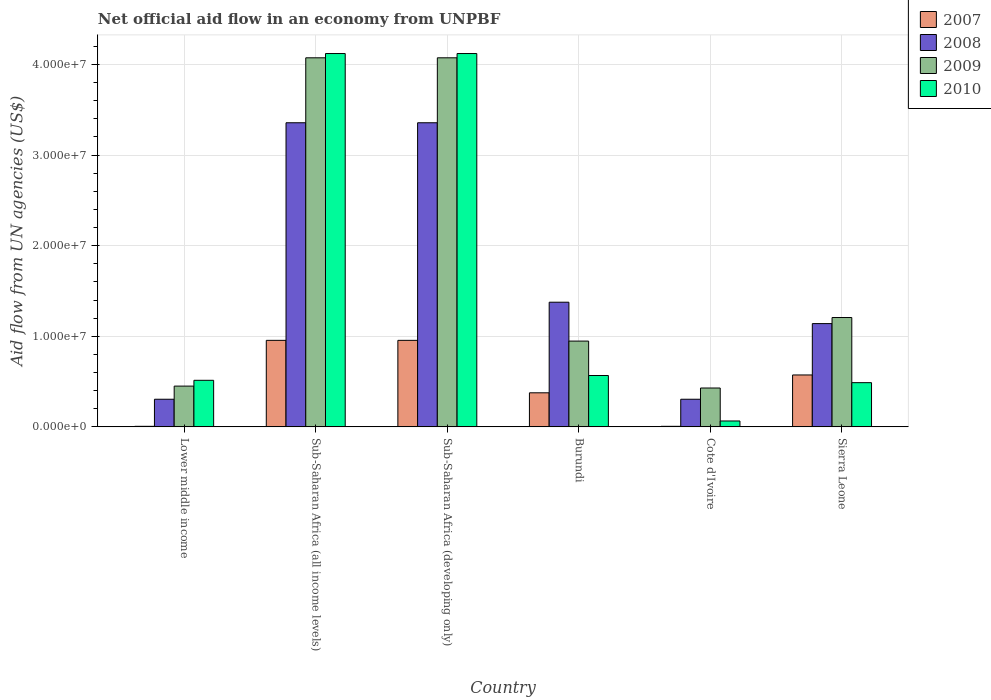How many different coloured bars are there?
Give a very brief answer. 4. How many groups of bars are there?
Keep it short and to the point. 6. How many bars are there on the 6th tick from the left?
Provide a short and direct response. 4. How many bars are there on the 1st tick from the right?
Your answer should be compact. 4. What is the label of the 5th group of bars from the left?
Provide a short and direct response. Cote d'Ivoire. In how many cases, is the number of bars for a given country not equal to the number of legend labels?
Offer a very short reply. 0. What is the net official aid flow in 2009 in Burundi?
Provide a succinct answer. 9.47e+06. Across all countries, what is the maximum net official aid flow in 2008?
Your response must be concise. 3.36e+07. Across all countries, what is the minimum net official aid flow in 2008?
Ensure brevity in your answer.  3.05e+06. In which country was the net official aid flow in 2007 maximum?
Provide a succinct answer. Sub-Saharan Africa (all income levels). In which country was the net official aid flow in 2007 minimum?
Your response must be concise. Lower middle income. What is the total net official aid flow in 2010 in the graph?
Your answer should be very brief. 9.88e+07. What is the difference between the net official aid flow in 2007 in Lower middle income and that in Sub-Saharan Africa (all income levels)?
Your answer should be compact. -9.49e+06. What is the difference between the net official aid flow in 2009 in Sierra Leone and the net official aid flow in 2010 in Sub-Saharan Africa (all income levels)?
Keep it short and to the point. -2.91e+07. What is the average net official aid flow in 2008 per country?
Provide a short and direct response. 1.64e+07. What is the difference between the net official aid flow of/in 2009 and net official aid flow of/in 2008 in Sub-Saharan Africa (all income levels)?
Offer a very short reply. 7.17e+06. In how many countries, is the net official aid flow in 2009 greater than 26000000 US$?
Offer a terse response. 2. What is the ratio of the net official aid flow in 2009 in Cote d'Ivoire to that in Lower middle income?
Keep it short and to the point. 0.95. Is the net official aid flow in 2008 in Burundi less than that in Sub-Saharan Africa (developing only)?
Make the answer very short. Yes. Is the difference between the net official aid flow in 2009 in Lower middle income and Sub-Saharan Africa (all income levels) greater than the difference between the net official aid flow in 2008 in Lower middle income and Sub-Saharan Africa (all income levels)?
Your answer should be very brief. No. What is the difference between the highest and the second highest net official aid flow in 2008?
Offer a very short reply. 1.98e+07. What is the difference between the highest and the lowest net official aid flow in 2010?
Make the answer very short. 4.06e+07. Is the sum of the net official aid flow in 2010 in Burundi and Sub-Saharan Africa (developing only) greater than the maximum net official aid flow in 2007 across all countries?
Your response must be concise. Yes. Are all the bars in the graph horizontal?
Offer a very short reply. No. How many countries are there in the graph?
Provide a succinct answer. 6. What is the difference between two consecutive major ticks on the Y-axis?
Keep it short and to the point. 1.00e+07. What is the title of the graph?
Provide a short and direct response. Net official aid flow in an economy from UNPBF. Does "2004" appear as one of the legend labels in the graph?
Keep it short and to the point. No. What is the label or title of the X-axis?
Offer a very short reply. Country. What is the label or title of the Y-axis?
Provide a short and direct response. Aid flow from UN agencies (US$). What is the Aid flow from UN agencies (US$) of 2007 in Lower middle income?
Give a very brief answer. 6.00e+04. What is the Aid flow from UN agencies (US$) of 2008 in Lower middle income?
Ensure brevity in your answer.  3.05e+06. What is the Aid flow from UN agencies (US$) of 2009 in Lower middle income?
Ensure brevity in your answer.  4.50e+06. What is the Aid flow from UN agencies (US$) in 2010 in Lower middle income?
Your answer should be compact. 5.14e+06. What is the Aid flow from UN agencies (US$) in 2007 in Sub-Saharan Africa (all income levels)?
Your answer should be compact. 9.55e+06. What is the Aid flow from UN agencies (US$) in 2008 in Sub-Saharan Africa (all income levels)?
Make the answer very short. 3.36e+07. What is the Aid flow from UN agencies (US$) of 2009 in Sub-Saharan Africa (all income levels)?
Provide a succinct answer. 4.07e+07. What is the Aid flow from UN agencies (US$) in 2010 in Sub-Saharan Africa (all income levels)?
Your answer should be very brief. 4.12e+07. What is the Aid flow from UN agencies (US$) in 2007 in Sub-Saharan Africa (developing only)?
Keep it short and to the point. 9.55e+06. What is the Aid flow from UN agencies (US$) of 2008 in Sub-Saharan Africa (developing only)?
Your response must be concise. 3.36e+07. What is the Aid flow from UN agencies (US$) in 2009 in Sub-Saharan Africa (developing only)?
Your response must be concise. 4.07e+07. What is the Aid flow from UN agencies (US$) of 2010 in Sub-Saharan Africa (developing only)?
Provide a short and direct response. 4.12e+07. What is the Aid flow from UN agencies (US$) in 2007 in Burundi?
Offer a very short reply. 3.76e+06. What is the Aid flow from UN agencies (US$) of 2008 in Burundi?
Ensure brevity in your answer.  1.38e+07. What is the Aid flow from UN agencies (US$) of 2009 in Burundi?
Offer a terse response. 9.47e+06. What is the Aid flow from UN agencies (US$) of 2010 in Burundi?
Ensure brevity in your answer.  5.67e+06. What is the Aid flow from UN agencies (US$) of 2008 in Cote d'Ivoire?
Make the answer very short. 3.05e+06. What is the Aid flow from UN agencies (US$) of 2009 in Cote d'Ivoire?
Offer a very short reply. 4.29e+06. What is the Aid flow from UN agencies (US$) in 2010 in Cote d'Ivoire?
Provide a succinct answer. 6.50e+05. What is the Aid flow from UN agencies (US$) in 2007 in Sierra Leone?
Offer a very short reply. 5.73e+06. What is the Aid flow from UN agencies (US$) of 2008 in Sierra Leone?
Make the answer very short. 1.14e+07. What is the Aid flow from UN agencies (US$) of 2009 in Sierra Leone?
Make the answer very short. 1.21e+07. What is the Aid flow from UN agencies (US$) of 2010 in Sierra Leone?
Keep it short and to the point. 4.88e+06. Across all countries, what is the maximum Aid flow from UN agencies (US$) of 2007?
Give a very brief answer. 9.55e+06. Across all countries, what is the maximum Aid flow from UN agencies (US$) in 2008?
Provide a succinct answer. 3.36e+07. Across all countries, what is the maximum Aid flow from UN agencies (US$) of 2009?
Provide a succinct answer. 4.07e+07. Across all countries, what is the maximum Aid flow from UN agencies (US$) of 2010?
Give a very brief answer. 4.12e+07. Across all countries, what is the minimum Aid flow from UN agencies (US$) of 2008?
Your answer should be very brief. 3.05e+06. Across all countries, what is the minimum Aid flow from UN agencies (US$) of 2009?
Ensure brevity in your answer.  4.29e+06. Across all countries, what is the minimum Aid flow from UN agencies (US$) in 2010?
Make the answer very short. 6.50e+05. What is the total Aid flow from UN agencies (US$) in 2007 in the graph?
Offer a terse response. 2.87e+07. What is the total Aid flow from UN agencies (US$) of 2008 in the graph?
Your answer should be compact. 9.84e+07. What is the total Aid flow from UN agencies (US$) of 2009 in the graph?
Provide a short and direct response. 1.12e+08. What is the total Aid flow from UN agencies (US$) of 2010 in the graph?
Keep it short and to the point. 9.88e+07. What is the difference between the Aid flow from UN agencies (US$) of 2007 in Lower middle income and that in Sub-Saharan Africa (all income levels)?
Offer a very short reply. -9.49e+06. What is the difference between the Aid flow from UN agencies (US$) of 2008 in Lower middle income and that in Sub-Saharan Africa (all income levels)?
Provide a short and direct response. -3.05e+07. What is the difference between the Aid flow from UN agencies (US$) of 2009 in Lower middle income and that in Sub-Saharan Africa (all income levels)?
Make the answer very short. -3.62e+07. What is the difference between the Aid flow from UN agencies (US$) of 2010 in Lower middle income and that in Sub-Saharan Africa (all income levels)?
Your answer should be very brief. -3.61e+07. What is the difference between the Aid flow from UN agencies (US$) of 2007 in Lower middle income and that in Sub-Saharan Africa (developing only)?
Offer a very short reply. -9.49e+06. What is the difference between the Aid flow from UN agencies (US$) in 2008 in Lower middle income and that in Sub-Saharan Africa (developing only)?
Your answer should be compact. -3.05e+07. What is the difference between the Aid flow from UN agencies (US$) of 2009 in Lower middle income and that in Sub-Saharan Africa (developing only)?
Provide a short and direct response. -3.62e+07. What is the difference between the Aid flow from UN agencies (US$) of 2010 in Lower middle income and that in Sub-Saharan Africa (developing only)?
Your answer should be compact. -3.61e+07. What is the difference between the Aid flow from UN agencies (US$) of 2007 in Lower middle income and that in Burundi?
Ensure brevity in your answer.  -3.70e+06. What is the difference between the Aid flow from UN agencies (US$) of 2008 in Lower middle income and that in Burundi?
Give a very brief answer. -1.07e+07. What is the difference between the Aid flow from UN agencies (US$) in 2009 in Lower middle income and that in Burundi?
Your answer should be very brief. -4.97e+06. What is the difference between the Aid flow from UN agencies (US$) in 2010 in Lower middle income and that in Burundi?
Your answer should be compact. -5.30e+05. What is the difference between the Aid flow from UN agencies (US$) in 2007 in Lower middle income and that in Cote d'Ivoire?
Offer a terse response. 0. What is the difference between the Aid flow from UN agencies (US$) in 2008 in Lower middle income and that in Cote d'Ivoire?
Make the answer very short. 0. What is the difference between the Aid flow from UN agencies (US$) in 2010 in Lower middle income and that in Cote d'Ivoire?
Your answer should be compact. 4.49e+06. What is the difference between the Aid flow from UN agencies (US$) in 2007 in Lower middle income and that in Sierra Leone?
Provide a succinct answer. -5.67e+06. What is the difference between the Aid flow from UN agencies (US$) in 2008 in Lower middle income and that in Sierra Leone?
Offer a terse response. -8.35e+06. What is the difference between the Aid flow from UN agencies (US$) of 2009 in Lower middle income and that in Sierra Leone?
Your answer should be compact. -7.57e+06. What is the difference between the Aid flow from UN agencies (US$) in 2010 in Lower middle income and that in Sierra Leone?
Ensure brevity in your answer.  2.60e+05. What is the difference between the Aid flow from UN agencies (US$) in 2010 in Sub-Saharan Africa (all income levels) and that in Sub-Saharan Africa (developing only)?
Offer a very short reply. 0. What is the difference between the Aid flow from UN agencies (US$) of 2007 in Sub-Saharan Africa (all income levels) and that in Burundi?
Keep it short and to the point. 5.79e+06. What is the difference between the Aid flow from UN agencies (US$) in 2008 in Sub-Saharan Africa (all income levels) and that in Burundi?
Keep it short and to the point. 1.98e+07. What is the difference between the Aid flow from UN agencies (US$) in 2009 in Sub-Saharan Africa (all income levels) and that in Burundi?
Make the answer very short. 3.13e+07. What is the difference between the Aid flow from UN agencies (US$) of 2010 in Sub-Saharan Africa (all income levels) and that in Burundi?
Give a very brief answer. 3.55e+07. What is the difference between the Aid flow from UN agencies (US$) in 2007 in Sub-Saharan Africa (all income levels) and that in Cote d'Ivoire?
Provide a short and direct response. 9.49e+06. What is the difference between the Aid flow from UN agencies (US$) in 2008 in Sub-Saharan Africa (all income levels) and that in Cote d'Ivoire?
Provide a succinct answer. 3.05e+07. What is the difference between the Aid flow from UN agencies (US$) of 2009 in Sub-Saharan Africa (all income levels) and that in Cote d'Ivoire?
Give a very brief answer. 3.64e+07. What is the difference between the Aid flow from UN agencies (US$) in 2010 in Sub-Saharan Africa (all income levels) and that in Cote d'Ivoire?
Keep it short and to the point. 4.06e+07. What is the difference between the Aid flow from UN agencies (US$) of 2007 in Sub-Saharan Africa (all income levels) and that in Sierra Leone?
Ensure brevity in your answer.  3.82e+06. What is the difference between the Aid flow from UN agencies (US$) of 2008 in Sub-Saharan Africa (all income levels) and that in Sierra Leone?
Your response must be concise. 2.22e+07. What is the difference between the Aid flow from UN agencies (US$) of 2009 in Sub-Saharan Africa (all income levels) and that in Sierra Leone?
Your response must be concise. 2.87e+07. What is the difference between the Aid flow from UN agencies (US$) in 2010 in Sub-Saharan Africa (all income levels) and that in Sierra Leone?
Your response must be concise. 3.63e+07. What is the difference between the Aid flow from UN agencies (US$) of 2007 in Sub-Saharan Africa (developing only) and that in Burundi?
Ensure brevity in your answer.  5.79e+06. What is the difference between the Aid flow from UN agencies (US$) in 2008 in Sub-Saharan Africa (developing only) and that in Burundi?
Your response must be concise. 1.98e+07. What is the difference between the Aid flow from UN agencies (US$) of 2009 in Sub-Saharan Africa (developing only) and that in Burundi?
Provide a short and direct response. 3.13e+07. What is the difference between the Aid flow from UN agencies (US$) in 2010 in Sub-Saharan Africa (developing only) and that in Burundi?
Your answer should be compact. 3.55e+07. What is the difference between the Aid flow from UN agencies (US$) of 2007 in Sub-Saharan Africa (developing only) and that in Cote d'Ivoire?
Your response must be concise. 9.49e+06. What is the difference between the Aid flow from UN agencies (US$) of 2008 in Sub-Saharan Africa (developing only) and that in Cote d'Ivoire?
Offer a terse response. 3.05e+07. What is the difference between the Aid flow from UN agencies (US$) in 2009 in Sub-Saharan Africa (developing only) and that in Cote d'Ivoire?
Your response must be concise. 3.64e+07. What is the difference between the Aid flow from UN agencies (US$) in 2010 in Sub-Saharan Africa (developing only) and that in Cote d'Ivoire?
Ensure brevity in your answer.  4.06e+07. What is the difference between the Aid flow from UN agencies (US$) in 2007 in Sub-Saharan Africa (developing only) and that in Sierra Leone?
Your answer should be very brief. 3.82e+06. What is the difference between the Aid flow from UN agencies (US$) of 2008 in Sub-Saharan Africa (developing only) and that in Sierra Leone?
Keep it short and to the point. 2.22e+07. What is the difference between the Aid flow from UN agencies (US$) of 2009 in Sub-Saharan Africa (developing only) and that in Sierra Leone?
Your answer should be very brief. 2.87e+07. What is the difference between the Aid flow from UN agencies (US$) of 2010 in Sub-Saharan Africa (developing only) and that in Sierra Leone?
Offer a very short reply. 3.63e+07. What is the difference between the Aid flow from UN agencies (US$) of 2007 in Burundi and that in Cote d'Ivoire?
Offer a terse response. 3.70e+06. What is the difference between the Aid flow from UN agencies (US$) in 2008 in Burundi and that in Cote d'Ivoire?
Provide a short and direct response. 1.07e+07. What is the difference between the Aid flow from UN agencies (US$) in 2009 in Burundi and that in Cote d'Ivoire?
Keep it short and to the point. 5.18e+06. What is the difference between the Aid flow from UN agencies (US$) of 2010 in Burundi and that in Cote d'Ivoire?
Provide a succinct answer. 5.02e+06. What is the difference between the Aid flow from UN agencies (US$) of 2007 in Burundi and that in Sierra Leone?
Offer a very short reply. -1.97e+06. What is the difference between the Aid flow from UN agencies (US$) of 2008 in Burundi and that in Sierra Leone?
Your answer should be very brief. 2.36e+06. What is the difference between the Aid flow from UN agencies (US$) of 2009 in Burundi and that in Sierra Leone?
Give a very brief answer. -2.60e+06. What is the difference between the Aid flow from UN agencies (US$) of 2010 in Burundi and that in Sierra Leone?
Give a very brief answer. 7.90e+05. What is the difference between the Aid flow from UN agencies (US$) of 2007 in Cote d'Ivoire and that in Sierra Leone?
Make the answer very short. -5.67e+06. What is the difference between the Aid flow from UN agencies (US$) of 2008 in Cote d'Ivoire and that in Sierra Leone?
Keep it short and to the point. -8.35e+06. What is the difference between the Aid flow from UN agencies (US$) of 2009 in Cote d'Ivoire and that in Sierra Leone?
Provide a short and direct response. -7.78e+06. What is the difference between the Aid flow from UN agencies (US$) in 2010 in Cote d'Ivoire and that in Sierra Leone?
Your answer should be compact. -4.23e+06. What is the difference between the Aid flow from UN agencies (US$) in 2007 in Lower middle income and the Aid flow from UN agencies (US$) in 2008 in Sub-Saharan Africa (all income levels)?
Make the answer very short. -3.35e+07. What is the difference between the Aid flow from UN agencies (US$) in 2007 in Lower middle income and the Aid flow from UN agencies (US$) in 2009 in Sub-Saharan Africa (all income levels)?
Ensure brevity in your answer.  -4.07e+07. What is the difference between the Aid flow from UN agencies (US$) in 2007 in Lower middle income and the Aid flow from UN agencies (US$) in 2010 in Sub-Saharan Africa (all income levels)?
Offer a very short reply. -4.12e+07. What is the difference between the Aid flow from UN agencies (US$) in 2008 in Lower middle income and the Aid flow from UN agencies (US$) in 2009 in Sub-Saharan Africa (all income levels)?
Provide a succinct answer. -3.77e+07. What is the difference between the Aid flow from UN agencies (US$) in 2008 in Lower middle income and the Aid flow from UN agencies (US$) in 2010 in Sub-Saharan Africa (all income levels)?
Your response must be concise. -3.82e+07. What is the difference between the Aid flow from UN agencies (US$) in 2009 in Lower middle income and the Aid flow from UN agencies (US$) in 2010 in Sub-Saharan Africa (all income levels)?
Provide a short and direct response. -3.67e+07. What is the difference between the Aid flow from UN agencies (US$) in 2007 in Lower middle income and the Aid flow from UN agencies (US$) in 2008 in Sub-Saharan Africa (developing only)?
Give a very brief answer. -3.35e+07. What is the difference between the Aid flow from UN agencies (US$) in 2007 in Lower middle income and the Aid flow from UN agencies (US$) in 2009 in Sub-Saharan Africa (developing only)?
Provide a succinct answer. -4.07e+07. What is the difference between the Aid flow from UN agencies (US$) in 2007 in Lower middle income and the Aid flow from UN agencies (US$) in 2010 in Sub-Saharan Africa (developing only)?
Provide a succinct answer. -4.12e+07. What is the difference between the Aid flow from UN agencies (US$) of 2008 in Lower middle income and the Aid flow from UN agencies (US$) of 2009 in Sub-Saharan Africa (developing only)?
Your response must be concise. -3.77e+07. What is the difference between the Aid flow from UN agencies (US$) of 2008 in Lower middle income and the Aid flow from UN agencies (US$) of 2010 in Sub-Saharan Africa (developing only)?
Your response must be concise. -3.82e+07. What is the difference between the Aid flow from UN agencies (US$) of 2009 in Lower middle income and the Aid flow from UN agencies (US$) of 2010 in Sub-Saharan Africa (developing only)?
Your response must be concise. -3.67e+07. What is the difference between the Aid flow from UN agencies (US$) in 2007 in Lower middle income and the Aid flow from UN agencies (US$) in 2008 in Burundi?
Your response must be concise. -1.37e+07. What is the difference between the Aid flow from UN agencies (US$) in 2007 in Lower middle income and the Aid flow from UN agencies (US$) in 2009 in Burundi?
Keep it short and to the point. -9.41e+06. What is the difference between the Aid flow from UN agencies (US$) of 2007 in Lower middle income and the Aid flow from UN agencies (US$) of 2010 in Burundi?
Offer a terse response. -5.61e+06. What is the difference between the Aid flow from UN agencies (US$) of 2008 in Lower middle income and the Aid flow from UN agencies (US$) of 2009 in Burundi?
Ensure brevity in your answer.  -6.42e+06. What is the difference between the Aid flow from UN agencies (US$) in 2008 in Lower middle income and the Aid flow from UN agencies (US$) in 2010 in Burundi?
Give a very brief answer. -2.62e+06. What is the difference between the Aid flow from UN agencies (US$) in 2009 in Lower middle income and the Aid flow from UN agencies (US$) in 2010 in Burundi?
Your response must be concise. -1.17e+06. What is the difference between the Aid flow from UN agencies (US$) in 2007 in Lower middle income and the Aid flow from UN agencies (US$) in 2008 in Cote d'Ivoire?
Offer a very short reply. -2.99e+06. What is the difference between the Aid flow from UN agencies (US$) in 2007 in Lower middle income and the Aid flow from UN agencies (US$) in 2009 in Cote d'Ivoire?
Your answer should be very brief. -4.23e+06. What is the difference between the Aid flow from UN agencies (US$) of 2007 in Lower middle income and the Aid flow from UN agencies (US$) of 2010 in Cote d'Ivoire?
Ensure brevity in your answer.  -5.90e+05. What is the difference between the Aid flow from UN agencies (US$) of 2008 in Lower middle income and the Aid flow from UN agencies (US$) of 2009 in Cote d'Ivoire?
Make the answer very short. -1.24e+06. What is the difference between the Aid flow from UN agencies (US$) in 2008 in Lower middle income and the Aid flow from UN agencies (US$) in 2010 in Cote d'Ivoire?
Keep it short and to the point. 2.40e+06. What is the difference between the Aid flow from UN agencies (US$) in 2009 in Lower middle income and the Aid flow from UN agencies (US$) in 2010 in Cote d'Ivoire?
Give a very brief answer. 3.85e+06. What is the difference between the Aid flow from UN agencies (US$) in 2007 in Lower middle income and the Aid flow from UN agencies (US$) in 2008 in Sierra Leone?
Ensure brevity in your answer.  -1.13e+07. What is the difference between the Aid flow from UN agencies (US$) in 2007 in Lower middle income and the Aid flow from UN agencies (US$) in 2009 in Sierra Leone?
Your response must be concise. -1.20e+07. What is the difference between the Aid flow from UN agencies (US$) of 2007 in Lower middle income and the Aid flow from UN agencies (US$) of 2010 in Sierra Leone?
Your response must be concise. -4.82e+06. What is the difference between the Aid flow from UN agencies (US$) of 2008 in Lower middle income and the Aid flow from UN agencies (US$) of 2009 in Sierra Leone?
Give a very brief answer. -9.02e+06. What is the difference between the Aid flow from UN agencies (US$) in 2008 in Lower middle income and the Aid flow from UN agencies (US$) in 2010 in Sierra Leone?
Your response must be concise. -1.83e+06. What is the difference between the Aid flow from UN agencies (US$) of 2009 in Lower middle income and the Aid flow from UN agencies (US$) of 2010 in Sierra Leone?
Offer a terse response. -3.80e+05. What is the difference between the Aid flow from UN agencies (US$) of 2007 in Sub-Saharan Africa (all income levels) and the Aid flow from UN agencies (US$) of 2008 in Sub-Saharan Africa (developing only)?
Your response must be concise. -2.40e+07. What is the difference between the Aid flow from UN agencies (US$) of 2007 in Sub-Saharan Africa (all income levels) and the Aid flow from UN agencies (US$) of 2009 in Sub-Saharan Africa (developing only)?
Provide a short and direct response. -3.12e+07. What is the difference between the Aid flow from UN agencies (US$) of 2007 in Sub-Saharan Africa (all income levels) and the Aid flow from UN agencies (US$) of 2010 in Sub-Saharan Africa (developing only)?
Make the answer very short. -3.17e+07. What is the difference between the Aid flow from UN agencies (US$) of 2008 in Sub-Saharan Africa (all income levels) and the Aid flow from UN agencies (US$) of 2009 in Sub-Saharan Africa (developing only)?
Ensure brevity in your answer.  -7.17e+06. What is the difference between the Aid flow from UN agencies (US$) in 2008 in Sub-Saharan Africa (all income levels) and the Aid flow from UN agencies (US$) in 2010 in Sub-Saharan Africa (developing only)?
Keep it short and to the point. -7.64e+06. What is the difference between the Aid flow from UN agencies (US$) of 2009 in Sub-Saharan Africa (all income levels) and the Aid flow from UN agencies (US$) of 2010 in Sub-Saharan Africa (developing only)?
Provide a short and direct response. -4.70e+05. What is the difference between the Aid flow from UN agencies (US$) in 2007 in Sub-Saharan Africa (all income levels) and the Aid flow from UN agencies (US$) in 2008 in Burundi?
Make the answer very short. -4.21e+06. What is the difference between the Aid flow from UN agencies (US$) in 2007 in Sub-Saharan Africa (all income levels) and the Aid flow from UN agencies (US$) in 2010 in Burundi?
Your answer should be compact. 3.88e+06. What is the difference between the Aid flow from UN agencies (US$) of 2008 in Sub-Saharan Africa (all income levels) and the Aid flow from UN agencies (US$) of 2009 in Burundi?
Offer a terse response. 2.41e+07. What is the difference between the Aid flow from UN agencies (US$) of 2008 in Sub-Saharan Africa (all income levels) and the Aid flow from UN agencies (US$) of 2010 in Burundi?
Make the answer very short. 2.79e+07. What is the difference between the Aid flow from UN agencies (US$) of 2009 in Sub-Saharan Africa (all income levels) and the Aid flow from UN agencies (US$) of 2010 in Burundi?
Offer a terse response. 3.51e+07. What is the difference between the Aid flow from UN agencies (US$) of 2007 in Sub-Saharan Africa (all income levels) and the Aid flow from UN agencies (US$) of 2008 in Cote d'Ivoire?
Keep it short and to the point. 6.50e+06. What is the difference between the Aid flow from UN agencies (US$) of 2007 in Sub-Saharan Africa (all income levels) and the Aid flow from UN agencies (US$) of 2009 in Cote d'Ivoire?
Your answer should be very brief. 5.26e+06. What is the difference between the Aid flow from UN agencies (US$) in 2007 in Sub-Saharan Africa (all income levels) and the Aid flow from UN agencies (US$) in 2010 in Cote d'Ivoire?
Keep it short and to the point. 8.90e+06. What is the difference between the Aid flow from UN agencies (US$) of 2008 in Sub-Saharan Africa (all income levels) and the Aid flow from UN agencies (US$) of 2009 in Cote d'Ivoire?
Give a very brief answer. 2.93e+07. What is the difference between the Aid flow from UN agencies (US$) of 2008 in Sub-Saharan Africa (all income levels) and the Aid flow from UN agencies (US$) of 2010 in Cote d'Ivoire?
Give a very brief answer. 3.29e+07. What is the difference between the Aid flow from UN agencies (US$) of 2009 in Sub-Saharan Africa (all income levels) and the Aid flow from UN agencies (US$) of 2010 in Cote d'Ivoire?
Your answer should be compact. 4.01e+07. What is the difference between the Aid flow from UN agencies (US$) in 2007 in Sub-Saharan Africa (all income levels) and the Aid flow from UN agencies (US$) in 2008 in Sierra Leone?
Provide a short and direct response. -1.85e+06. What is the difference between the Aid flow from UN agencies (US$) of 2007 in Sub-Saharan Africa (all income levels) and the Aid flow from UN agencies (US$) of 2009 in Sierra Leone?
Your response must be concise. -2.52e+06. What is the difference between the Aid flow from UN agencies (US$) in 2007 in Sub-Saharan Africa (all income levels) and the Aid flow from UN agencies (US$) in 2010 in Sierra Leone?
Your response must be concise. 4.67e+06. What is the difference between the Aid flow from UN agencies (US$) of 2008 in Sub-Saharan Africa (all income levels) and the Aid flow from UN agencies (US$) of 2009 in Sierra Leone?
Your response must be concise. 2.15e+07. What is the difference between the Aid flow from UN agencies (US$) in 2008 in Sub-Saharan Africa (all income levels) and the Aid flow from UN agencies (US$) in 2010 in Sierra Leone?
Give a very brief answer. 2.87e+07. What is the difference between the Aid flow from UN agencies (US$) in 2009 in Sub-Saharan Africa (all income levels) and the Aid flow from UN agencies (US$) in 2010 in Sierra Leone?
Your response must be concise. 3.59e+07. What is the difference between the Aid flow from UN agencies (US$) of 2007 in Sub-Saharan Africa (developing only) and the Aid flow from UN agencies (US$) of 2008 in Burundi?
Provide a succinct answer. -4.21e+06. What is the difference between the Aid flow from UN agencies (US$) in 2007 in Sub-Saharan Africa (developing only) and the Aid flow from UN agencies (US$) in 2010 in Burundi?
Make the answer very short. 3.88e+06. What is the difference between the Aid flow from UN agencies (US$) of 2008 in Sub-Saharan Africa (developing only) and the Aid flow from UN agencies (US$) of 2009 in Burundi?
Make the answer very short. 2.41e+07. What is the difference between the Aid flow from UN agencies (US$) of 2008 in Sub-Saharan Africa (developing only) and the Aid flow from UN agencies (US$) of 2010 in Burundi?
Offer a very short reply. 2.79e+07. What is the difference between the Aid flow from UN agencies (US$) in 2009 in Sub-Saharan Africa (developing only) and the Aid flow from UN agencies (US$) in 2010 in Burundi?
Ensure brevity in your answer.  3.51e+07. What is the difference between the Aid flow from UN agencies (US$) of 2007 in Sub-Saharan Africa (developing only) and the Aid flow from UN agencies (US$) of 2008 in Cote d'Ivoire?
Your response must be concise. 6.50e+06. What is the difference between the Aid flow from UN agencies (US$) of 2007 in Sub-Saharan Africa (developing only) and the Aid flow from UN agencies (US$) of 2009 in Cote d'Ivoire?
Your answer should be compact. 5.26e+06. What is the difference between the Aid flow from UN agencies (US$) in 2007 in Sub-Saharan Africa (developing only) and the Aid flow from UN agencies (US$) in 2010 in Cote d'Ivoire?
Offer a very short reply. 8.90e+06. What is the difference between the Aid flow from UN agencies (US$) of 2008 in Sub-Saharan Africa (developing only) and the Aid flow from UN agencies (US$) of 2009 in Cote d'Ivoire?
Give a very brief answer. 2.93e+07. What is the difference between the Aid flow from UN agencies (US$) in 2008 in Sub-Saharan Africa (developing only) and the Aid flow from UN agencies (US$) in 2010 in Cote d'Ivoire?
Your response must be concise. 3.29e+07. What is the difference between the Aid flow from UN agencies (US$) in 2009 in Sub-Saharan Africa (developing only) and the Aid flow from UN agencies (US$) in 2010 in Cote d'Ivoire?
Give a very brief answer. 4.01e+07. What is the difference between the Aid flow from UN agencies (US$) in 2007 in Sub-Saharan Africa (developing only) and the Aid flow from UN agencies (US$) in 2008 in Sierra Leone?
Your response must be concise. -1.85e+06. What is the difference between the Aid flow from UN agencies (US$) in 2007 in Sub-Saharan Africa (developing only) and the Aid flow from UN agencies (US$) in 2009 in Sierra Leone?
Provide a succinct answer. -2.52e+06. What is the difference between the Aid flow from UN agencies (US$) of 2007 in Sub-Saharan Africa (developing only) and the Aid flow from UN agencies (US$) of 2010 in Sierra Leone?
Offer a very short reply. 4.67e+06. What is the difference between the Aid flow from UN agencies (US$) in 2008 in Sub-Saharan Africa (developing only) and the Aid flow from UN agencies (US$) in 2009 in Sierra Leone?
Make the answer very short. 2.15e+07. What is the difference between the Aid flow from UN agencies (US$) in 2008 in Sub-Saharan Africa (developing only) and the Aid flow from UN agencies (US$) in 2010 in Sierra Leone?
Provide a succinct answer. 2.87e+07. What is the difference between the Aid flow from UN agencies (US$) in 2009 in Sub-Saharan Africa (developing only) and the Aid flow from UN agencies (US$) in 2010 in Sierra Leone?
Offer a very short reply. 3.59e+07. What is the difference between the Aid flow from UN agencies (US$) in 2007 in Burundi and the Aid flow from UN agencies (US$) in 2008 in Cote d'Ivoire?
Offer a very short reply. 7.10e+05. What is the difference between the Aid flow from UN agencies (US$) of 2007 in Burundi and the Aid flow from UN agencies (US$) of 2009 in Cote d'Ivoire?
Your response must be concise. -5.30e+05. What is the difference between the Aid flow from UN agencies (US$) in 2007 in Burundi and the Aid flow from UN agencies (US$) in 2010 in Cote d'Ivoire?
Provide a short and direct response. 3.11e+06. What is the difference between the Aid flow from UN agencies (US$) in 2008 in Burundi and the Aid flow from UN agencies (US$) in 2009 in Cote d'Ivoire?
Keep it short and to the point. 9.47e+06. What is the difference between the Aid flow from UN agencies (US$) of 2008 in Burundi and the Aid flow from UN agencies (US$) of 2010 in Cote d'Ivoire?
Offer a terse response. 1.31e+07. What is the difference between the Aid flow from UN agencies (US$) of 2009 in Burundi and the Aid flow from UN agencies (US$) of 2010 in Cote d'Ivoire?
Make the answer very short. 8.82e+06. What is the difference between the Aid flow from UN agencies (US$) of 2007 in Burundi and the Aid flow from UN agencies (US$) of 2008 in Sierra Leone?
Your response must be concise. -7.64e+06. What is the difference between the Aid flow from UN agencies (US$) in 2007 in Burundi and the Aid flow from UN agencies (US$) in 2009 in Sierra Leone?
Your response must be concise. -8.31e+06. What is the difference between the Aid flow from UN agencies (US$) in 2007 in Burundi and the Aid flow from UN agencies (US$) in 2010 in Sierra Leone?
Your answer should be very brief. -1.12e+06. What is the difference between the Aid flow from UN agencies (US$) of 2008 in Burundi and the Aid flow from UN agencies (US$) of 2009 in Sierra Leone?
Provide a short and direct response. 1.69e+06. What is the difference between the Aid flow from UN agencies (US$) in 2008 in Burundi and the Aid flow from UN agencies (US$) in 2010 in Sierra Leone?
Make the answer very short. 8.88e+06. What is the difference between the Aid flow from UN agencies (US$) in 2009 in Burundi and the Aid flow from UN agencies (US$) in 2010 in Sierra Leone?
Provide a short and direct response. 4.59e+06. What is the difference between the Aid flow from UN agencies (US$) of 2007 in Cote d'Ivoire and the Aid flow from UN agencies (US$) of 2008 in Sierra Leone?
Provide a short and direct response. -1.13e+07. What is the difference between the Aid flow from UN agencies (US$) in 2007 in Cote d'Ivoire and the Aid flow from UN agencies (US$) in 2009 in Sierra Leone?
Your response must be concise. -1.20e+07. What is the difference between the Aid flow from UN agencies (US$) in 2007 in Cote d'Ivoire and the Aid flow from UN agencies (US$) in 2010 in Sierra Leone?
Offer a terse response. -4.82e+06. What is the difference between the Aid flow from UN agencies (US$) of 2008 in Cote d'Ivoire and the Aid flow from UN agencies (US$) of 2009 in Sierra Leone?
Provide a short and direct response. -9.02e+06. What is the difference between the Aid flow from UN agencies (US$) in 2008 in Cote d'Ivoire and the Aid flow from UN agencies (US$) in 2010 in Sierra Leone?
Your response must be concise. -1.83e+06. What is the difference between the Aid flow from UN agencies (US$) in 2009 in Cote d'Ivoire and the Aid flow from UN agencies (US$) in 2010 in Sierra Leone?
Make the answer very short. -5.90e+05. What is the average Aid flow from UN agencies (US$) in 2007 per country?
Your answer should be compact. 4.78e+06. What is the average Aid flow from UN agencies (US$) in 2008 per country?
Provide a succinct answer. 1.64e+07. What is the average Aid flow from UN agencies (US$) in 2009 per country?
Provide a short and direct response. 1.86e+07. What is the average Aid flow from UN agencies (US$) in 2010 per country?
Ensure brevity in your answer.  1.65e+07. What is the difference between the Aid flow from UN agencies (US$) of 2007 and Aid flow from UN agencies (US$) of 2008 in Lower middle income?
Make the answer very short. -2.99e+06. What is the difference between the Aid flow from UN agencies (US$) in 2007 and Aid flow from UN agencies (US$) in 2009 in Lower middle income?
Give a very brief answer. -4.44e+06. What is the difference between the Aid flow from UN agencies (US$) of 2007 and Aid flow from UN agencies (US$) of 2010 in Lower middle income?
Your response must be concise. -5.08e+06. What is the difference between the Aid flow from UN agencies (US$) in 2008 and Aid flow from UN agencies (US$) in 2009 in Lower middle income?
Ensure brevity in your answer.  -1.45e+06. What is the difference between the Aid flow from UN agencies (US$) in 2008 and Aid flow from UN agencies (US$) in 2010 in Lower middle income?
Provide a short and direct response. -2.09e+06. What is the difference between the Aid flow from UN agencies (US$) in 2009 and Aid flow from UN agencies (US$) in 2010 in Lower middle income?
Offer a terse response. -6.40e+05. What is the difference between the Aid flow from UN agencies (US$) of 2007 and Aid flow from UN agencies (US$) of 2008 in Sub-Saharan Africa (all income levels)?
Give a very brief answer. -2.40e+07. What is the difference between the Aid flow from UN agencies (US$) of 2007 and Aid flow from UN agencies (US$) of 2009 in Sub-Saharan Africa (all income levels)?
Your answer should be compact. -3.12e+07. What is the difference between the Aid flow from UN agencies (US$) in 2007 and Aid flow from UN agencies (US$) in 2010 in Sub-Saharan Africa (all income levels)?
Your answer should be very brief. -3.17e+07. What is the difference between the Aid flow from UN agencies (US$) of 2008 and Aid flow from UN agencies (US$) of 2009 in Sub-Saharan Africa (all income levels)?
Provide a short and direct response. -7.17e+06. What is the difference between the Aid flow from UN agencies (US$) of 2008 and Aid flow from UN agencies (US$) of 2010 in Sub-Saharan Africa (all income levels)?
Offer a terse response. -7.64e+06. What is the difference between the Aid flow from UN agencies (US$) in 2009 and Aid flow from UN agencies (US$) in 2010 in Sub-Saharan Africa (all income levels)?
Provide a succinct answer. -4.70e+05. What is the difference between the Aid flow from UN agencies (US$) in 2007 and Aid flow from UN agencies (US$) in 2008 in Sub-Saharan Africa (developing only)?
Your answer should be very brief. -2.40e+07. What is the difference between the Aid flow from UN agencies (US$) in 2007 and Aid flow from UN agencies (US$) in 2009 in Sub-Saharan Africa (developing only)?
Make the answer very short. -3.12e+07. What is the difference between the Aid flow from UN agencies (US$) of 2007 and Aid flow from UN agencies (US$) of 2010 in Sub-Saharan Africa (developing only)?
Your response must be concise. -3.17e+07. What is the difference between the Aid flow from UN agencies (US$) in 2008 and Aid flow from UN agencies (US$) in 2009 in Sub-Saharan Africa (developing only)?
Provide a short and direct response. -7.17e+06. What is the difference between the Aid flow from UN agencies (US$) of 2008 and Aid flow from UN agencies (US$) of 2010 in Sub-Saharan Africa (developing only)?
Keep it short and to the point. -7.64e+06. What is the difference between the Aid flow from UN agencies (US$) of 2009 and Aid flow from UN agencies (US$) of 2010 in Sub-Saharan Africa (developing only)?
Offer a terse response. -4.70e+05. What is the difference between the Aid flow from UN agencies (US$) in 2007 and Aid flow from UN agencies (US$) in 2008 in Burundi?
Ensure brevity in your answer.  -1.00e+07. What is the difference between the Aid flow from UN agencies (US$) of 2007 and Aid flow from UN agencies (US$) of 2009 in Burundi?
Give a very brief answer. -5.71e+06. What is the difference between the Aid flow from UN agencies (US$) of 2007 and Aid flow from UN agencies (US$) of 2010 in Burundi?
Make the answer very short. -1.91e+06. What is the difference between the Aid flow from UN agencies (US$) of 2008 and Aid flow from UN agencies (US$) of 2009 in Burundi?
Provide a succinct answer. 4.29e+06. What is the difference between the Aid flow from UN agencies (US$) in 2008 and Aid flow from UN agencies (US$) in 2010 in Burundi?
Give a very brief answer. 8.09e+06. What is the difference between the Aid flow from UN agencies (US$) in 2009 and Aid flow from UN agencies (US$) in 2010 in Burundi?
Keep it short and to the point. 3.80e+06. What is the difference between the Aid flow from UN agencies (US$) in 2007 and Aid flow from UN agencies (US$) in 2008 in Cote d'Ivoire?
Make the answer very short. -2.99e+06. What is the difference between the Aid flow from UN agencies (US$) in 2007 and Aid flow from UN agencies (US$) in 2009 in Cote d'Ivoire?
Your response must be concise. -4.23e+06. What is the difference between the Aid flow from UN agencies (US$) of 2007 and Aid flow from UN agencies (US$) of 2010 in Cote d'Ivoire?
Keep it short and to the point. -5.90e+05. What is the difference between the Aid flow from UN agencies (US$) of 2008 and Aid flow from UN agencies (US$) of 2009 in Cote d'Ivoire?
Your response must be concise. -1.24e+06. What is the difference between the Aid flow from UN agencies (US$) in 2008 and Aid flow from UN agencies (US$) in 2010 in Cote d'Ivoire?
Offer a very short reply. 2.40e+06. What is the difference between the Aid flow from UN agencies (US$) in 2009 and Aid flow from UN agencies (US$) in 2010 in Cote d'Ivoire?
Your response must be concise. 3.64e+06. What is the difference between the Aid flow from UN agencies (US$) in 2007 and Aid flow from UN agencies (US$) in 2008 in Sierra Leone?
Provide a succinct answer. -5.67e+06. What is the difference between the Aid flow from UN agencies (US$) in 2007 and Aid flow from UN agencies (US$) in 2009 in Sierra Leone?
Provide a succinct answer. -6.34e+06. What is the difference between the Aid flow from UN agencies (US$) of 2007 and Aid flow from UN agencies (US$) of 2010 in Sierra Leone?
Your response must be concise. 8.50e+05. What is the difference between the Aid flow from UN agencies (US$) in 2008 and Aid flow from UN agencies (US$) in 2009 in Sierra Leone?
Offer a terse response. -6.70e+05. What is the difference between the Aid flow from UN agencies (US$) of 2008 and Aid flow from UN agencies (US$) of 2010 in Sierra Leone?
Provide a succinct answer. 6.52e+06. What is the difference between the Aid flow from UN agencies (US$) in 2009 and Aid flow from UN agencies (US$) in 2010 in Sierra Leone?
Your response must be concise. 7.19e+06. What is the ratio of the Aid flow from UN agencies (US$) of 2007 in Lower middle income to that in Sub-Saharan Africa (all income levels)?
Make the answer very short. 0.01. What is the ratio of the Aid flow from UN agencies (US$) of 2008 in Lower middle income to that in Sub-Saharan Africa (all income levels)?
Provide a succinct answer. 0.09. What is the ratio of the Aid flow from UN agencies (US$) in 2009 in Lower middle income to that in Sub-Saharan Africa (all income levels)?
Ensure brevity in your answer.  0.11. What is the ratio of the Aid flow from UN agencies (US$) in 2010 in Lower middle income to that in Sub-Saharan Africa (all income levels)?
Give a very brief answer. 0.12. What is the ratio of the Aid flow from UN agencies (US$) of 2007 in Lower middle income to that in Sub-Saharan Africa (developing only)?
Keep it short and to the point. 0.01. What is the ratio of the Aid flow from UN agencies (US$) in 2008 in Lower middle income to that in Sub-Saharan Africa (developing only)?
Give a very brief answer. 0.09. What is the ratio of the Aid flow from UN agencies (US$) in 2009 in Lower middle income to that in Sub-Saharan Africa (developing only)?
Ensure brevity in your answer.  0.11. What is the ratio of the Aid flow from UN agencies (US$) in 2010 in Lower middle income to that in Sub-Saharan Africa (developing only)?
Provide a short and direct response. 0.12. What is the ratio of the Aid flow from UN agencies (US$) of 2007 in Lower middle income to that in Burundi?
Provide a succinct answer. 0.02. What is the ratio of the Aid flow from UN agencies (US$) of 2008 in Lower middle income to that in Burundi?
Your answer should be compact. 0.22. What is the ratio of the Aid flow from UN agencies (US$) of 2009 in Lower middle income to that in Burundi?
Your response must be concise. 0.48. What is the ratio of the Aid flow from UN agencies (US$) in 2010 in Lower middle income to that in Burundi?
Provide a succinct answer. 0.91. What is the ratio of the Aid flow from UN agencies (US$) of 2007 in Lower middle income to that in Cote d'Ivoire?
Keep it short and to the point. 1. What is the ratio of the Aid flow from UN agencies (US$) in 2009 in Lower middle income to that in Cote d'Ivoire?
Your answer should be very brief. 1.05. What is the ratio of the Aid flow from UN agencies (US$) of 2010 in Lower middle income to that in Cote d'Ivoire?
Provide a short and direct response. 7.91. What is the ratio of the Aid flow from UN agencies (US$) in 2007 in Lower middle income to that in Sierra Leone?
Provide a short and direct response. 0.01. What is the ratio of the Aid flow from UN agencies (US$) in 2008 in Lower middle income to that in Sierra Leone?
Offer a terse response. 0.27. What is the ratio of the Aid flow from UN agencies (US$) of 2009 in Lower middle income to that in Sierra Leone?
Keep it short and to the point. 0.37. What is the ratio of the Aid flow from UN agencies (US$) of 2010 in Lower middle income to that in Sierra Leone?
Your answer should be very brief. 1.05. What is the ratio of the Aid flow from UN agencies (US$) of 2007 in Sub-Saharan Africa (all income levels) to that in Sub-Saharan Africa (developing only)?
Keep it short and to the point. 1. What is the ratio of the Aid flow from UN agencies (US$) of 2007 in Sub-Saharan Africa (all income levels) to that in Burundi?
Keep it short and to the point. 2.54. What is the ratio of the Aid flow from UN agencies (US$) in 2008 in Sub-Saharan Africa (all income levels) to that in Burundi?
Your response must be concise. 2.44. What is the ratio of the Aid flow from UN agencies (US$) of 2009 in Sub-Saharan Africa (all income levels) to that in Burundi?
Your answer should be very brief. 4.3. What is the ratio of the Aid flow from UN agencies (US$) of 2010 in Sub-Saharan Africa (all income levels) to that in Burundi?
Offer a terse response. 7.27. What is the ratio of the Aid flow from UN agencies (US$) of 2007 in Sub-Saharan Africa (all income levels) to that in Cote d'Ivoire?
Give a very brief answer. 159.17. What is the ratio of the Aid flow from UN agencies (US$) in 2008 in Sub-Saharan Africa (all income levels) to that in Cote d'Ivoire?
Provide a short and direct response. 11.01. What is the ratio of the Aid flow from UN agencies (US$) in 2009 in Sub-Saharan Africa (all income levels) to that in Cote d'Ivoire?
Offer a terse response. 9.5. What is the ratio of the Aid flow from UN agencies (US$) of 2010 in Sub-Saharan Africa (all income levels) to that in Cote d'Ivoire?
Ensure brevity in your answer.  63.4. What is the ratio of the Aid flow from UN agencies (US$) of 2007 in Sub-Saharan Africa (all income levels) to that in Sierra Leone?
Offer a very short reply. 1.67. What is the ratio of the Aid flow from UN agencies (US$) in 2008 in Sub-Saharan Africa (all income levels) to that in Sierra Leone?
Ensure brevity in your answer.  2.94. What is the ratio of the Aid flow from UN agencies (US$) in 2009 in Sub-Saharan Africa (all income levels) to that in Sierra Leone?
Offer a very short reply. 3.38. What is the ratio of the Aid flow from UN agencies (US$) of 2010 in Sub-Saharan Africa (all income levels) to that in Sierra Leone?
Your answer should be very brief. 8.44. What is the ratio of the Aid flow from UN agencies (US$) in 2007 in Sub-Saharan Africa (developing only) to that in Burundi?
Make the answer very short. 2.54. What is the ratio of the Aid flow from UN agencies (US$) of 2008 in Sub-Saharan Africa (developing only) to that in Burundi?
Give a very brief answer. 2.44. What is the ratio of the Aid flow from UN agencies (US$) of 2009 in Sub-Saharan Africa (developing only) to that in Burundi?
Provide a short and direct response. 4.3. What is the ratio of the Aid flow from UN agencies (US$) in 2010 in Sub-Saharan Africa (developing only) to that in Burundi?
Your answer should be compact. 7.27. What is the ratio of the Aid flow from UN agencies (US$) in 2007 in Sub-Saharan Africa (developing only) to that in Cote d'Ivoire?
Offer a terse response. 159.17. What is the ratio of the Aid flow from UN agencies (US$) of 2008 in Sub-Saharan Africa (developing only) to that in Cote d'Ivoire?
Your response must be concise. 11.01. What is the ratio of the Aid flow from UN agencies (US$) of 2009 in Sub-Saharan Africa (developing only) to that in Cote d'Ivoire?
Your answer should be very brief. 9.5. What is the ratio of the Aid flow from UN agencies (US$) of 2010 in Sub-Saharan Africa (developing only) to that in Cote d'Ivoire?
Keep it short and to the point. 63.4. What is the ratio of the Aid flow from UN agencies (US$) in 2007 in Sub-Saharan Africa (developing only) to that in Sierra Leone?
Your answer should be compact. 1.67. What is the ratio of the Aid flow from UN agencies (US$) of 2008 in Sub-Saharan Africa (developing only) to that in Sierra Leone?
Your answer should be very brief. 2.94. What is the ratio of the Aid flow from UN agencies (US$) of 2009 in Sub-Saharan Africa (developing only) to that in Sierra Leone?
Your answer should be compact. 3.38. What is the ratio of the Aid flow from UN agencies (US$) in 2010 in Sub-Saharan Africa (developing only) to that in Sierra Leone?
Give a very brief answer. 8.44. What is the ratio of the Aid flow from UN agencies (US$) in 2007 in Burundi to that in Cote d'Ivoire?
Ensure brevity in your answer.  62.67. What is the ratio of the Aid flow from UN agencies (US$) in 2008 in Burundi to that in Cote d'Ivoire?
Keep it short and to the point. 4.51. What is the ratio of the Aid flow from UN agencies (US$) of 2009 in Burundi to that in Cote d'Ivoire?
Make the answer very short. 2.21. What is the ratio of the Aid flow from UN agencies (US$) of 2010 in Burundi to that in Cote d'Ivoire?
Ensure brevity in your answer.  8.72. What is the ratio of the Aid flow from UN agencies (US$) in 2007 in Burundi to that in Sierra Leone?
Offer a very short reply. 0.66. What is the ratio of the Aid flow from UN agencies (US$) in 2008 in Burundi to that in Sierra Leone?
Ensure brevity in your answer.  1.21. What is the ratio of the Aid flow from UN agencies (US$) of 2009 in Burundi to that in Sierra Leone?
Give a very brief answer. 0.78. What is the ratio of the Aid flow from UN agencies (US$) in 2010 in Burundi to that in Sierra Leone?
Make the answer very short. 1.16. What is the ratio of the Aid flow from UN agencies (US$) in 2007 in Cote d'Ivoire to that in Sierra Leone?
Make the answer very short. 0.01. What is the ratio of the Aid flow from UN agencies (US$) in 2008 in Cote d'Ivoire to that in Sierra Leone?
Give a very brief answer. 0.27. What is the ratio of the Aid flow from UN agencies (US$) in 2009 in Cote d'Ivoire to that in Sierra Leone?
Offer a very short reply. 0.36. What is the ratio of the Aid flow from UN agencies (US$) of 2010 in Cote d'Ivoire to that in Sierra Leone?
Provide a short and direct response. 0.13. What is the difference between the highest and the second highest Aid flow from UN agencies (US$) of 2008?
Provide a succinct answer. 0. What is the difference between the highest and the second highest Aid flow from UN agencies (US$) in 2010?
Give a very brief answer. 0. What is the difference between the highest and the lowest Aid flow from UN agencies (US$) in 2007?
Give a very brief answer. 9.49e+06. What is the difference between the highest and the lowest Aid flow from UN agencies (US$) in 2008?
Provide a succinct answer. 3.05e+07. What is the difference between the highest and the lowest Aid flow from UN agencies (US$) of 2009?
Provide a short and direct response. 3.64e+07. What is the difference between the highest and the lowest Aid flow from UN agencies (US$) of 2010?
Your response must be concise. 4.06e+07. 